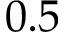<formula> <loc_0><loc_0><loc_500><loc_500>0 . 5</formula> 